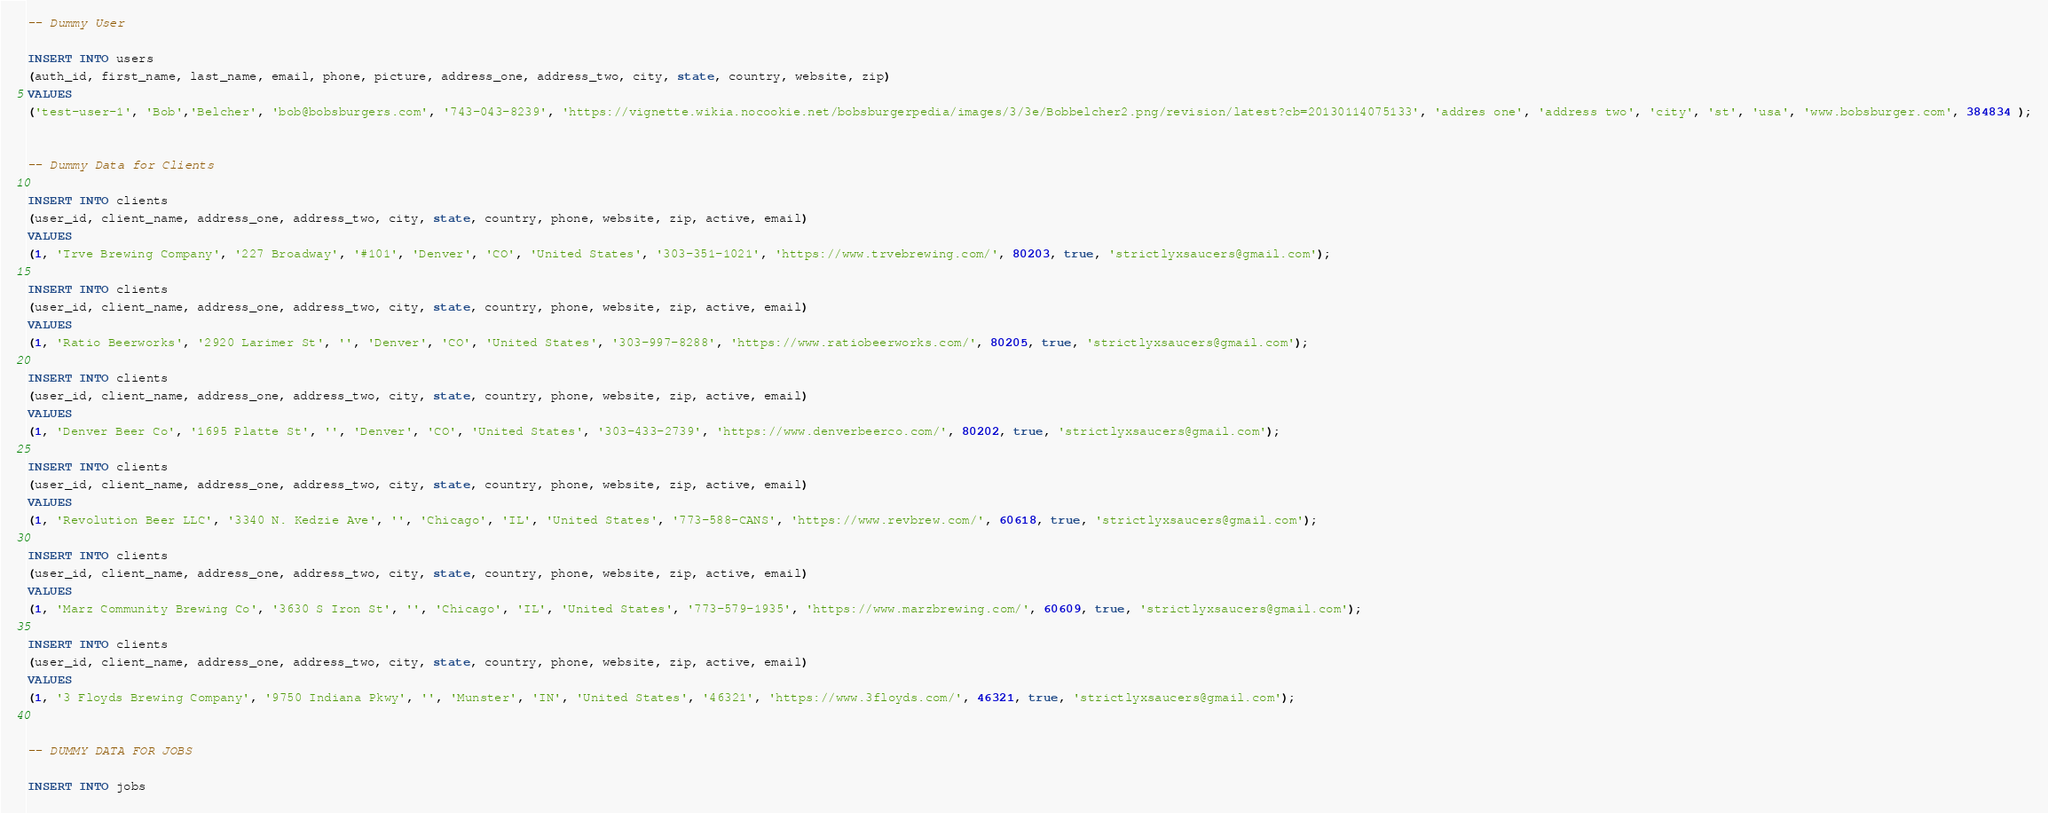Convert code to text. <code><loc_0><loc_0><loc_500><loc_500><_SQL_>-- Dummy User

INSERT INTO users
(auth_id, first_name, last_name, email, phone, picture, address_one, address_two, city, state, country, website, zip)
VALUES
('test-user-1', 'Bob','Belcher', 'bob@bobsburgers.com', '743-043-8239', 'https://vignette.wikia.nocookie.net/bobsburgerpedia/images/3/3e/Bobbelcher2.png/revision/latest?cb=20130114075133', 'addres one', 'address two', 'city', 'st', 'usa', 'www.bobsburger.com', 384834 );


-- Dummy Data for Clients

INSERT INTO clients
(user_id, client_name, address_one, address_two, city, state, country, phone, website, zip, active, email)
VALUES
(1, 'Trve Brewing Company', '227 Broadway', '#101', 'Denver', 'CO', 'United States', '303-351-1021', 'https://www.trvebrewing.com/', 80203, true, 'strictlyxsaucers@gmail.com');

INSERT INTO clients
(user_id, client_name, address_one, address_two, city, state, country, phone, website, zip, active, email)
VALUES
(1, 'Ratio Beerworks', '2920 Larimer St', '', 'Denver', 'CO', 'United States', '303-997-8288', 'https://www.ratiobeerworks.com/', 80205, true, 'strictlyxsaucers@gmail.com');

INSERT INTO clients
(user_id, client_name, address_one, address_two, city, state, country, phone, website, zip, active, email)
VALUES
(1, 'Denver Beer Co', '1695 Platte St', '', 'Denver', 'CO', 'United States', '303-433-2739', 'https://www.denverbeerco.com/', 80202, true, 'strictlyxsaucers@gmail.com');

INSERT INTO clients
(user_id, client_name, address_one, address_two, city, state, country, phone, website, zip, active, email)
VALUES
(1, 'Revolution Beer LLC', '3340 N. Kedzie Ave', '', 'Chicago', 'IL', 'United States', '773-588-CANS', 'https://www.revbrew.com/', 60618, true, 'strictlyxsaucers@gmail.com');

INSERT INTO clients
(user_id, client_name, address_one, address_two, city, state, country, phone, website, zip, active, email)
VALUES
(1, 'Marz Community Brewing Co', '3630 S Iron St', '', 'Chicago', 'IL', 'United States', '773-579-1935', 'https://www.marzbrewing.com/', 60609, true, 'strictlyxsaucers@gmail.com');

INSERT INTO clients
(user_id, client_name, address_one, address_two, city, state, country, phone, website, zip, active, email)
VALUES
(1, '3 Floyds Brewing Company', '9750 Indiana Pkwy', '', 'Munster', 'IN', 'United States', '46321', 'https://www.3floyds.com/', 46321, true, 'strictlyxsaucers@gmail.com');


-- DUMMY DATA FOR JOBS

INSERT INTO jobs</code> 